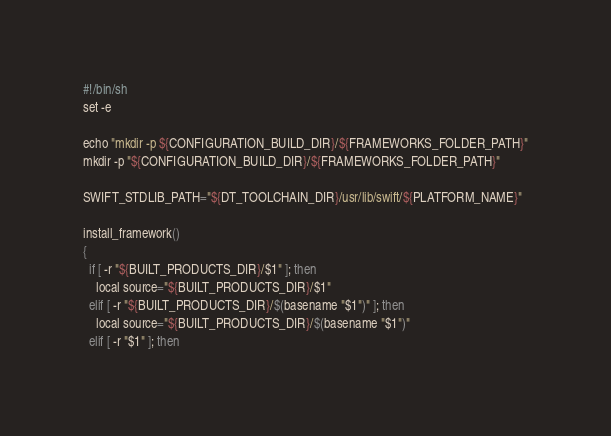Convert code to text. <code><loc_0><loc_0><loc_500><loc_500><_Bash_>#!/bin/sh
set -e

echo "mkdir -p ${CONFIGURATION_BUILD_DIR}/${FRAMEWORKS_FOLDER_PATH}"
mkdir -p "${CONFIGURATION_BUILD_DIR}/${FRAMEWORKS_FOLDER_PATH}"

SWIFT_STDLIB_PATH="${DT_TOOLCHAIN_DIR}/usr/lib/swift/${PLATFORM_NAME}"

install_framework()
{
  if [ -r "${BUILT_PRODUCTS_DIR}/$1" ]; then
    local source="${BUILT_PRODUCTS_DIR}/$1"
  elif [ -r "${BUILT_PRODUCTS_DIR}/$(basename "$1")" ]; then
    local source="${BUILT_PRODUCTS_DIR}/$(basename "$1")"
  elif [ -r "$1" ]; then</code> 